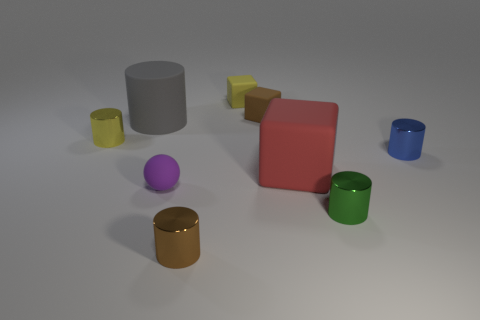What insights can you provide about the lighting and shadows seen in the image? The lighting in the image is diffused, casting soft shadows that lightly outline the shapes of the objects on the light gray surface. The angle of the light suggests a single light source positioned above and slightly to the front-right of the scene, creating a calm ambiance with hints of a professional or studio setting. 